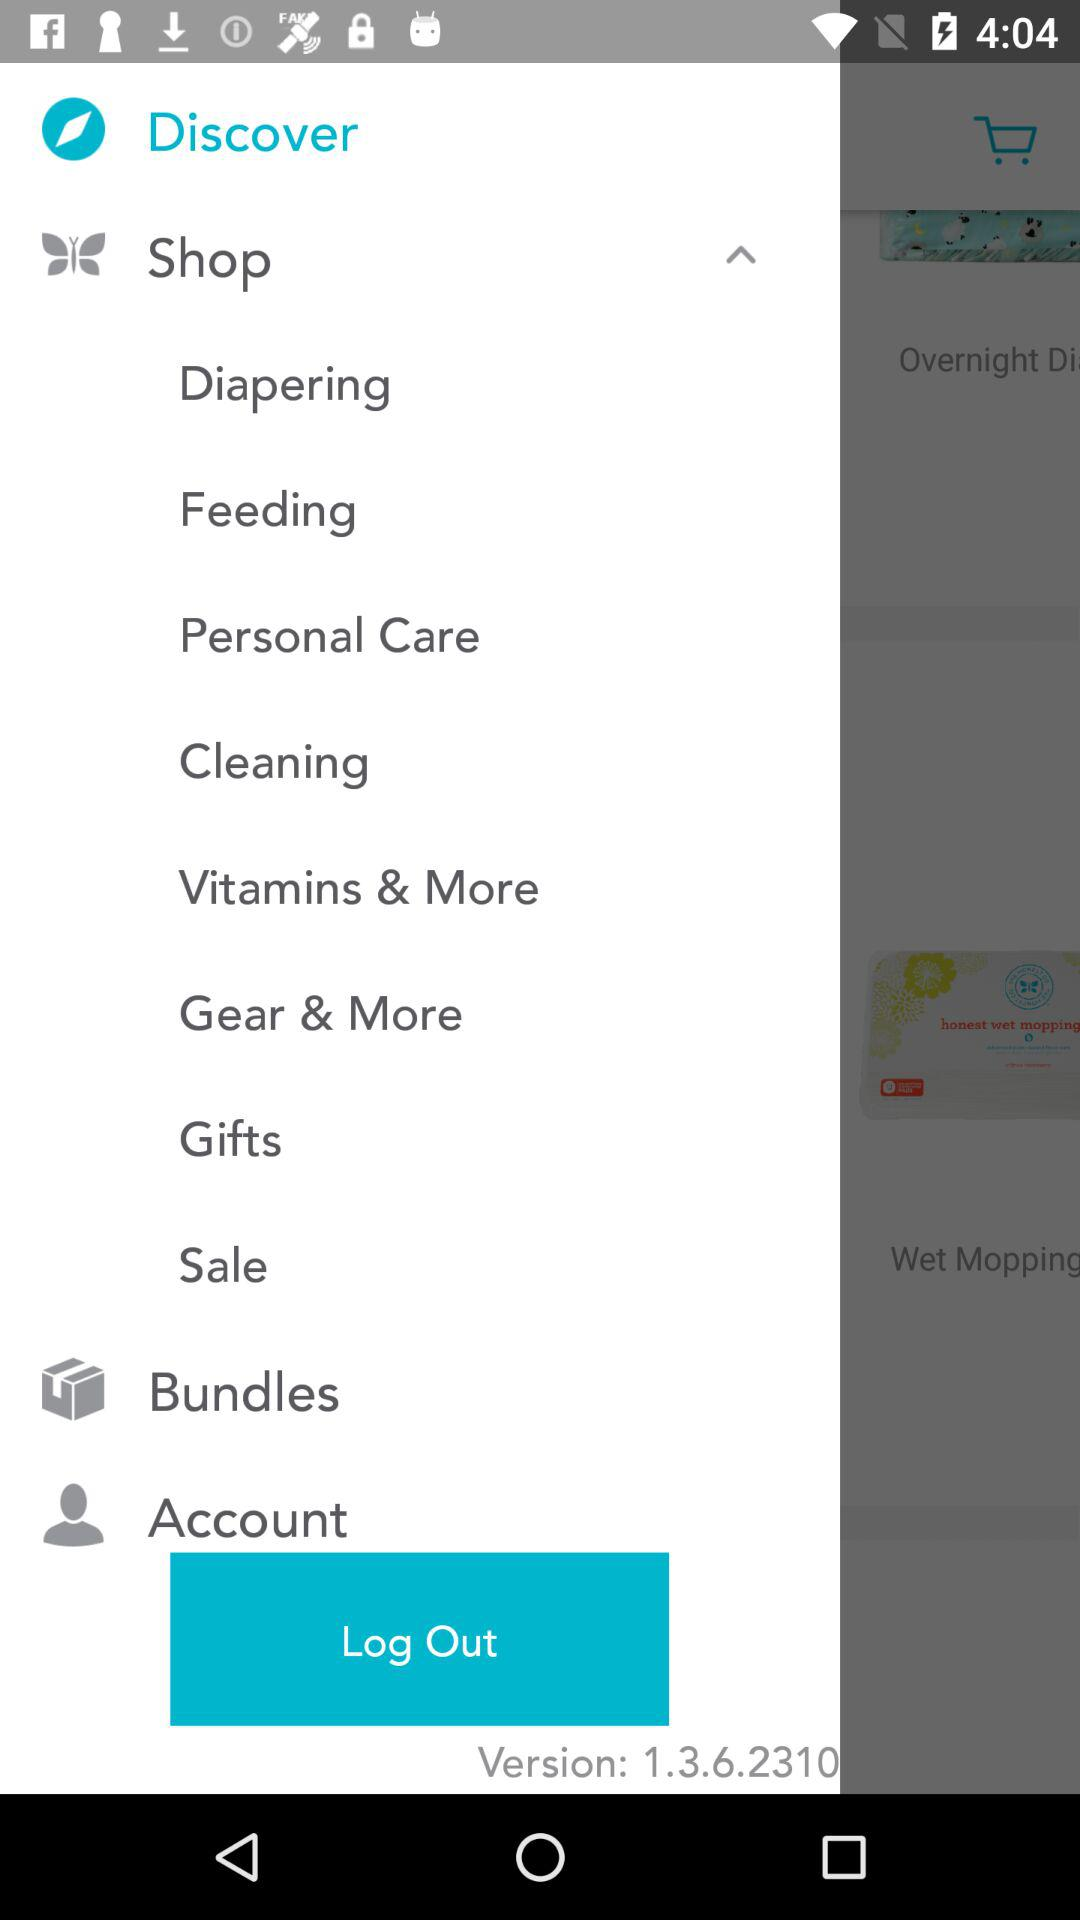Define the name of application?
When the provided information is insufficient, respond with <no answer>. <no answer> 